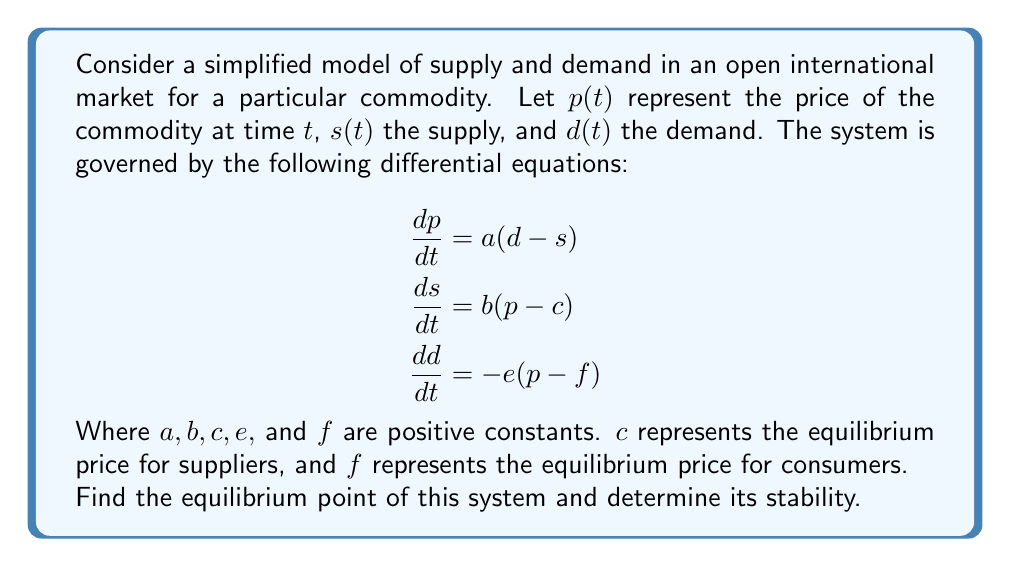Can you answer this question? To solve this problem, we'll follow these steps:

1) Find the equilibrium point:
   At equilibrium, all derivatives are zero. So we set each equation to zero:

   $$\begin{aligned}
   0 &= a(d - s) \\
   0 &= b(p - c) \\
   0 &= -e(p - f)
   \end{aligned}$$

2) Solve these equations:
   From the second equation: $p = c$
   From the third equation: $p = f$
   Therefore, at equilibrium: $c = f$
   From the first equation: $d = s$

   So the equilibrium point is $(p^*, s^*, d^*) = (c, s^*, s^*)$, where $s^*$ can be any value.

3) Analyze stability:
   To determine stability, we need to linearize the system around the equilibrium point and find the eigenvalues of the Jacobian matrix.

   The Jacobian matrix is:

   $$J = \begin{bmatrix}
   0 & -a & a \\
   b & 0 & 0 \\
   -e & 0 & 0
   \end{bmatrix}$$

4) Find the characteristic equation:
   $$\det(J - \lambda I) = -\lambda^3 - abe - \lambda ae = 0$$

5) Solve for eigenvalues:
   $$\lambda(\lambda^2 + ae) = -abe$$
   
   One eigenvalue is clearly 0. For the other two:
   $$\lambda^2 + ae = -abe/\lambda$$
   
   Solving this quadratic equation:
   $$\lambda = \pm i\sqrt{abe}$$

6) Interpret results:
   We have one zero eigenvalue and two purely imaginary eigenvalues. This indicates that the equilibrium is neutrally stable. The system will oscillate around the equilibrium point without converging or diverging.
Answer: Equilibrium point: $(c, s^*, s^*)$, neutrally stable. 